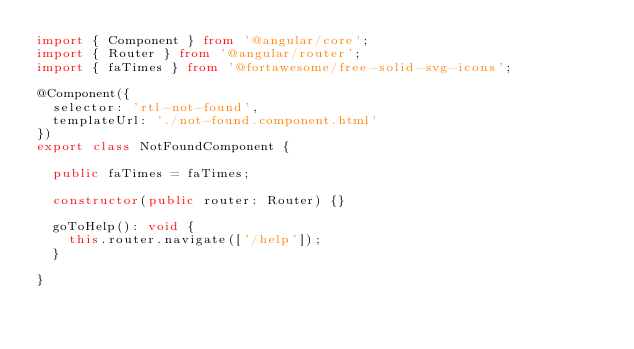Convert code to text. <code><loc_0><loc_0><loc_500><loc_500><_TypeScript_>import { Component } from '@angular/core';
import { Router } from '@angular/router';
import { faTimes } from '@fortawesome/free-solid-svg-icons';

@Component({
  selector: 'rtl-not-found',
  templateUrl: './not-found.component.html'
})
export class NotFoundComponent {

  public faTimes = faTimes;

  constructor(public router: Router) {}

  goToHelp(): void {
    this.router.navigate(['/help']);
  }

}
</code> 